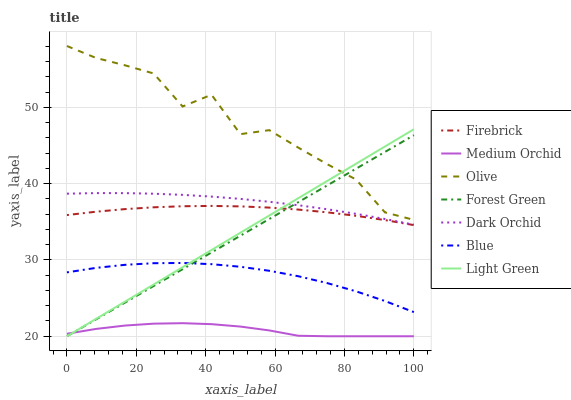Does Medium Orchid have the minimum area under the curve?
Answer yes or no. Yes. Does Olive have the maximum area under the curve?
Answer yes or no. Yes. Does Firebrick have the minimum area under the curve?
Answer yes or no. No. Does Firebrick have the maximum area under the curve?
Answer yes or no. No. Is Light Green the smoothest?
Answer yes or no. Yes. Is Olive the roughest?
Answer yes or no. Yes. Is Firebrick the smoothest?
Answer yes or no. No. Is Firebrick the roughest?
Answer yes or no. No. Does Medium Orchid have the lowest value?
Answer yes or no. Yes. Does Firebrick have the lowest value?
Answer yes or no. No. Does Olive have the highest value?
Answer yes or no. Yes. Does Firebrick have the highest value?
Answer yes or no. No. Is Medium Orchid less than Dark Orchid?
Answer yes or no. Yes. Is Dark Orchid greater than Firebrick?
Answer yes or no. Yes. Does Dark Orchid intersect Light Green?
Answer yes or no. Yes. Is Dark Orchid less than Light Green?
Answer yes or no. No. Is Dark Orchid greater than Light Green?
Answer yes or no. No. Does Medium Orchid intersect Dark Orchid?
Answer yes or no. No. 